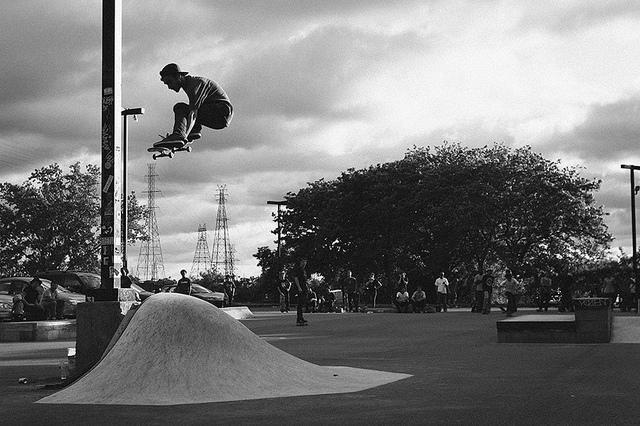How many people are in the photo?
Give a very brief answer. 2. How many levels does the bus have?
Give a very brief answer. 0. 